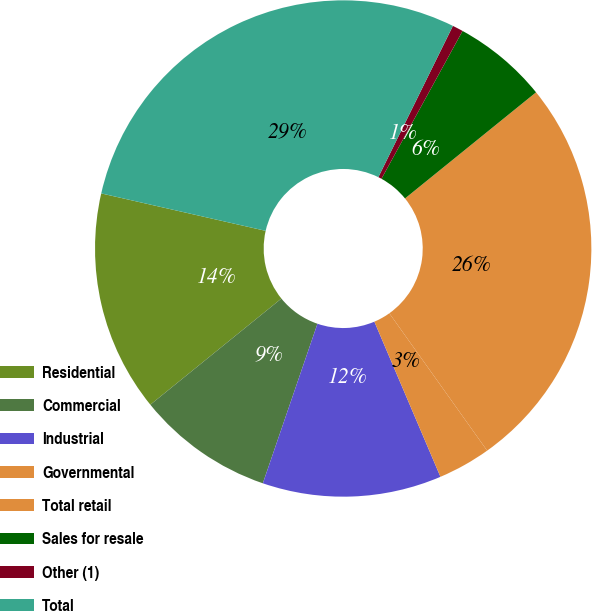Convert chart to OTSL. <chart><loc_0><loc_0><loc_500><loc_500><pie_chart><fcel>Residential<fcel>Commercial<fcel>Industrial<fcel>Governmental<fcel>Total retail<fcel>Sales for resale<fcel>Other (1)<fcel>Total<nl><fcel>14.4%<fcel>8.92%<fcel>11.66%<fcel>3.44%<fcel>25.99%<fcel>6.18%<fcel>0.7%<fcel>28.73%<nl></chart> 